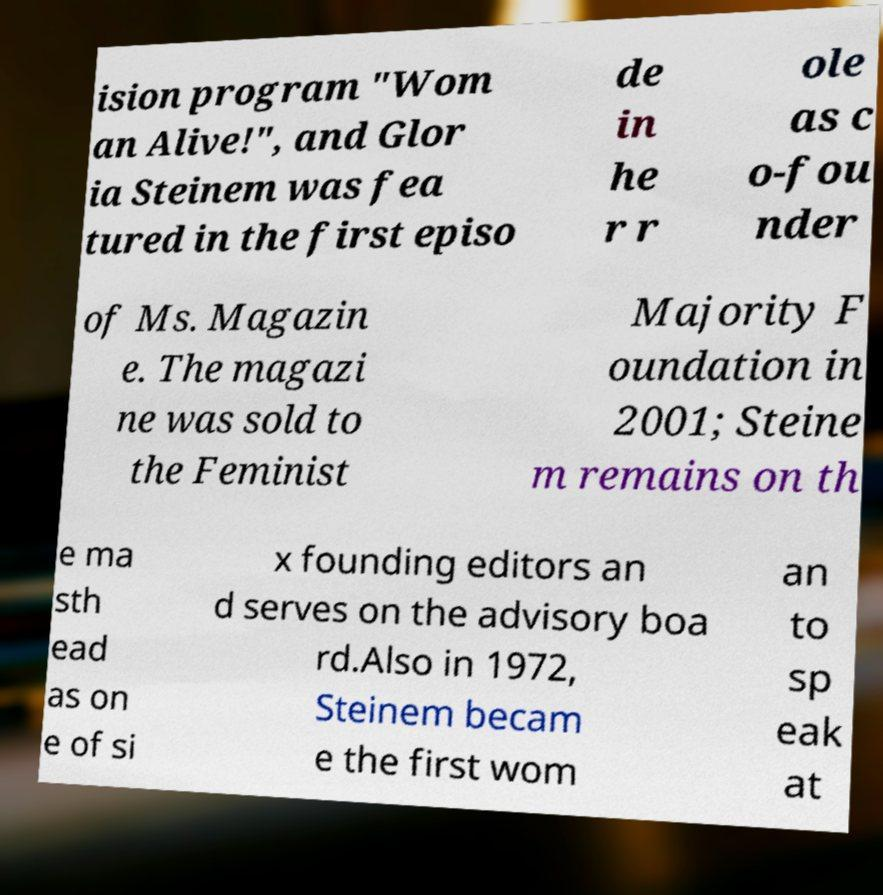Please read and relay the text visible in this image. What does it say? ision program "Wom an Alive!", and Glor ia Steinem was fea tured in the first episo de in he r r ole as c o-fou nder of Ms. Magazin e. The magazi ne was sold to the Feminist Majority F oundation in 2001; Steine m remains on th e ma sth ead as on e of si x founding editors an d serves on the advisory boa rd.Also in 1972, Steinem becam e the first wom an to sp eak at 